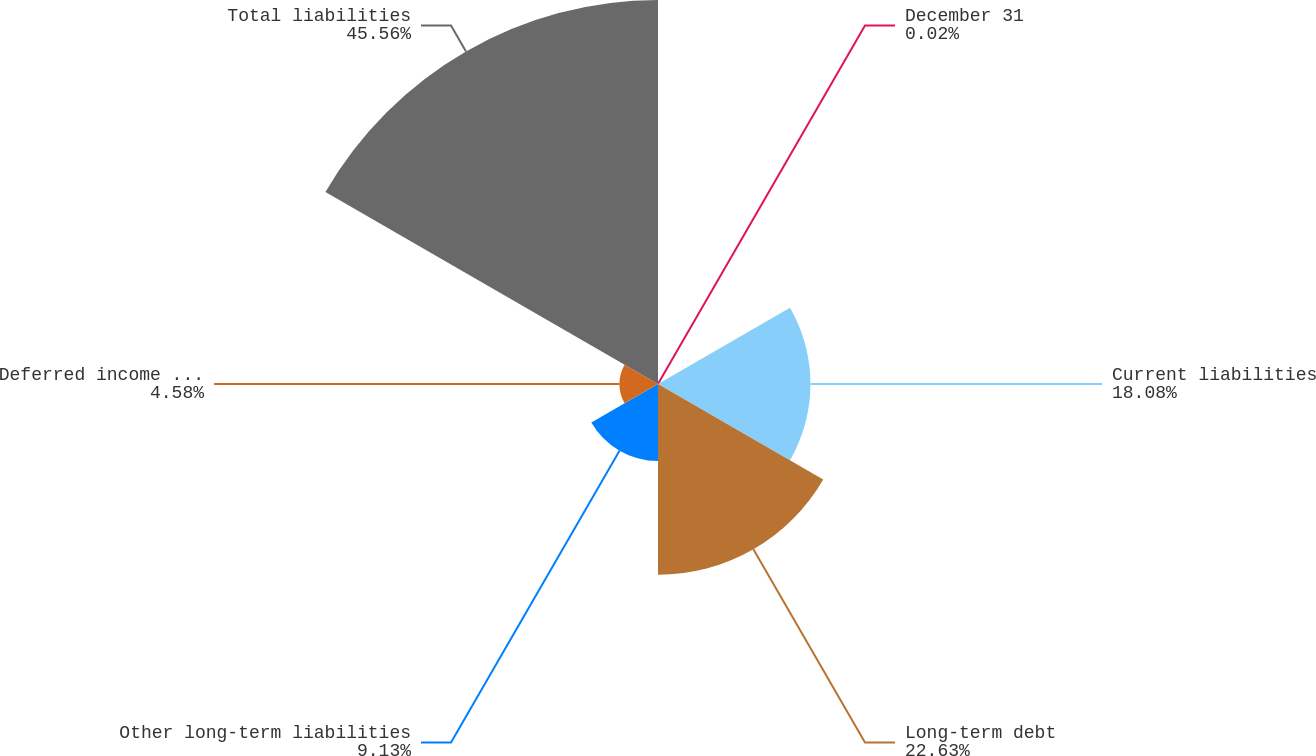Convert chart. <chart><loc_0><loc_0><loc_500><loc_500><pie_chart><fcel>December 31<fcel>Current liabilities<fcel>Long-term debt<fcel>Other long-term liabilities<fcel>Deferred income taxes<fcel>Total liabilities<nl><fcel>0.02%<fcel>18.08%<fcel>22.63%<fcel>9.13%<fcel>4.58%<fcel>45.55%<nl></chart> 